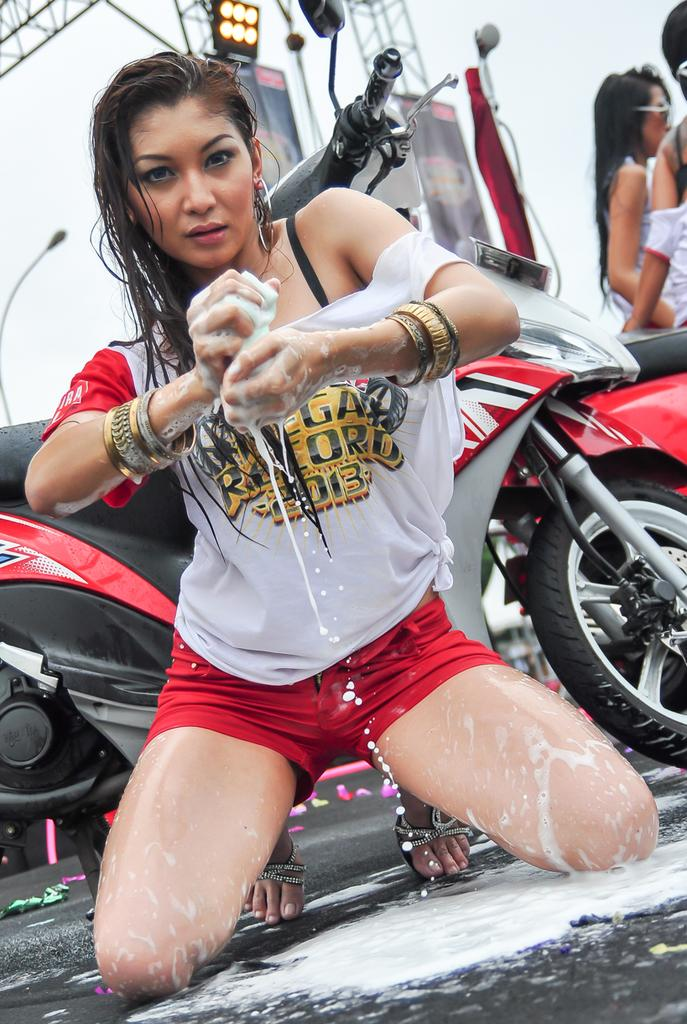What is the person in the image doing? The person is sitting on their knees in the image. What can be seen in the background of the image? There is a motorbike, two persons standing, and the sky visible in the background of the image. What additional equipment is present in the image? Focus lights, banners, and a lighting truss are present in the image. What type of bag is the person holding in the image? There is no bag visible in the image. What time of day is it in the image, considering the afternoon? The time of day cannot be determined from the image, and the provided fact about the afternoon is not relevant to the image. 